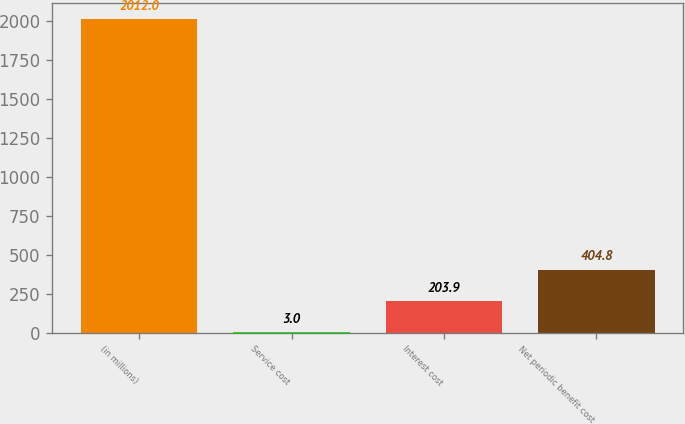Convert chart to OTSL. <chart><loc_0><loc_0><loc_500><loc_500><bar_chart><fcel>(in millions)<fcel>Service cost<fcel>Interest cost<fcel>Net periodic benefit cost<nl><fcel>2012<fcel>3<fcel>203.9<fcel>404.8<nl></chart> 